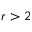Convert formula to latex. <formula><loc_0><loc_0><loc_500><loc_500>r > 2</formula> 